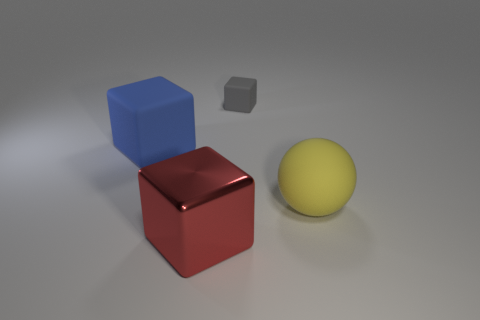Is there anything else that has the same material as the big red block?
Offer a terse response. No. What is the size of the metal block?
Ensure brevity in your answer.  Large. Does the tiny object have the same shape as the thing that is on the left side of the big red block?
Offer a terse response. Yes. There is a large cube that is the same material as the small block; what color is it?
Provide a short and direct response. Blue. What is the size of the rubber thing that is on the left side of the red object?
Your response must be concise. Large. Are there fewer small blocks on the right side of the tiny thing than tiny green matte blocks?
Offer a very short reply. No. Is the shiny cube the same color as the small block?
Your answer should be very brief. No. Is there any other thing that is the same shape as the gray matte object?
Keep it short and to the point. Yes. Are there fewer large gray objects than gray objects?
Provide a short and direct response. Yes. What is the color of the large block that is behind the large shiny object left of the rubber sphere?
Your answer should be very brief. Blue. 